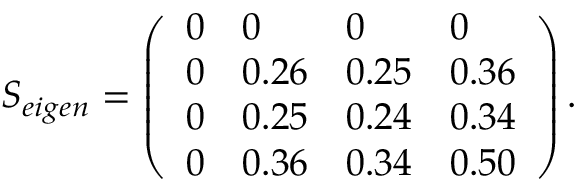<formula> <loc_0><loc_0><loc_500><loc_500>\begin{array} { r } { { { S } _ { e i g e n } } = \left ( \begin{array} { l l l l } { 0 } & { 0 } & { 0 } & { 0 } \\ { 0 } & { 0 . 2 6 } & { 0 . 2 5 } & { 0 . 3 6 } \\ { 0 } & { 0 . 2 5 } & { 0 . 2 4 } & { 0 . 3 4 } \\ { 0 } & { 0 . 3 6 } & { 0 . 3 4 } & { 0 . 5 0 } \end{array} \right ) . } \end{array}</formula> 